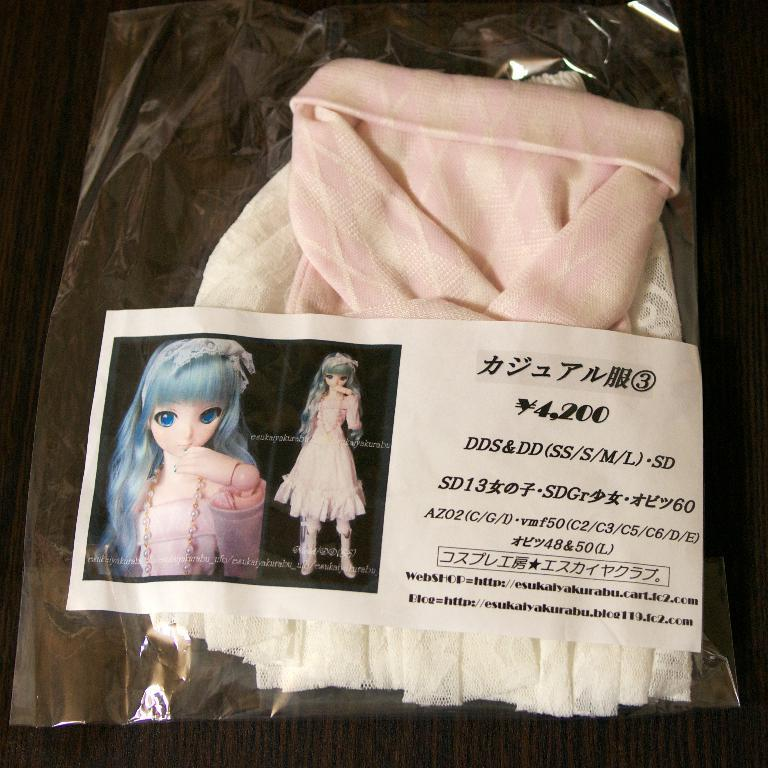What is in the image that is related to clothing? There is a dress in the image. How is the dress being stored or protected? The dress is in a cover. What can be seen on the cover? There is a label on the cover. What is depicted on the label? There is a photo of a doll on the label. What additional information is provided on the label? There is some text on the label. Can you describe the flock of icicles hanging from the dress in the image? There are no icicles present in the image; the dress is in a cover with a label featuring a photo of a doll. 